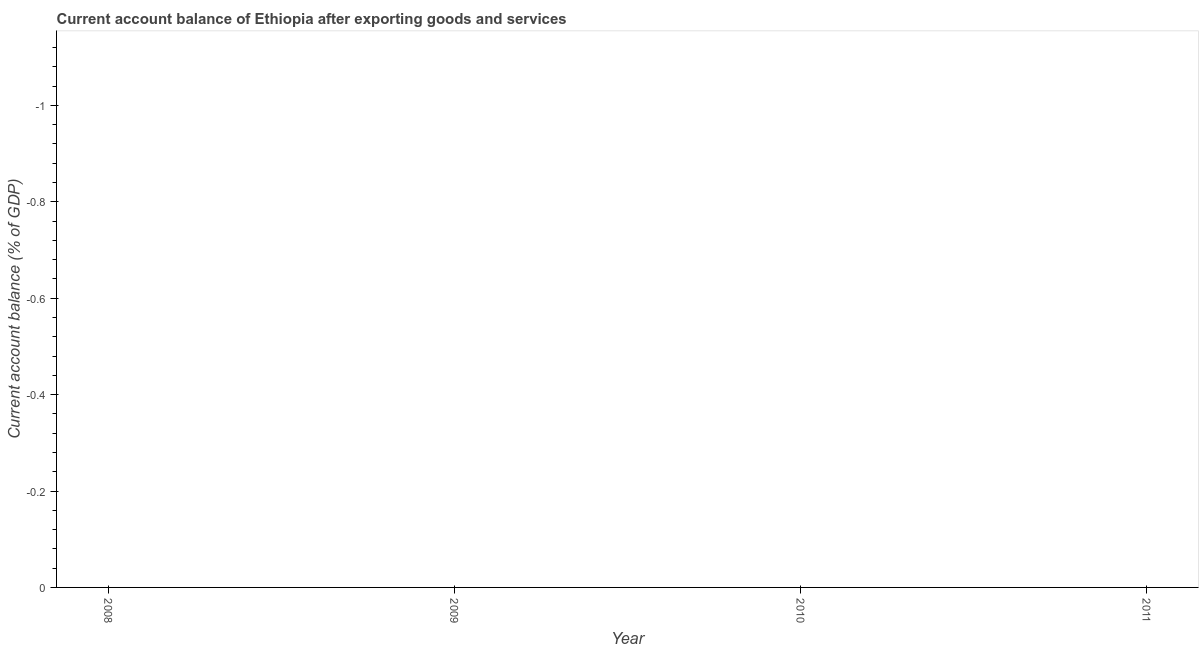In how many years, is the current account balance greater than the average current account balance taken over all years?
Provide a short and direct response. 0. Does the current account balance monotonically increase over the years?
Provide a short and direct response. No. How many dotlines are there?
Your answer should be compact. 0. How many years are there in the graph?
Offer a terse response. 4. What is the difference between two consecutive major ticks on the Y-axis?
Offer a terse response. 0.2. Are the values on the major ticks of Y-axis written in scientific E-notation?
Give a very brief answer. No. Does the graph contain any zero values?
Make the answer very short. Yes. What is the title of the graph?
Your answer should be very brief. Current account balance of Ethiopia after exporting goods and services. What is the label or title of the Y-axis?
Your answer should be very brief. Current account balance (% of GDP). What is the Current account balance (% of GDP) in 2008?
Give a very brief answer. 0. What is the Current account balance (% of GDP) in 2009?
Give a very brief answer. 0. What is the Current account balance (% of GDP) in 2010?
Give a very brief answer. 0. 